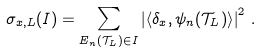Convert formula to latex. <formula><loc_0><loc_0><loc_500><loc_500>\sigma _ { x , L } ( I ) = \sum _ { E _ { n } ( \mathcal { T } _ { L } ) \in I } \left | \left \langle \delta _ { x } , \psi _ { n } ( \mathcal { T } _ { L } ) \right \rangle \right | ^ { 2 } \, .</formula> 